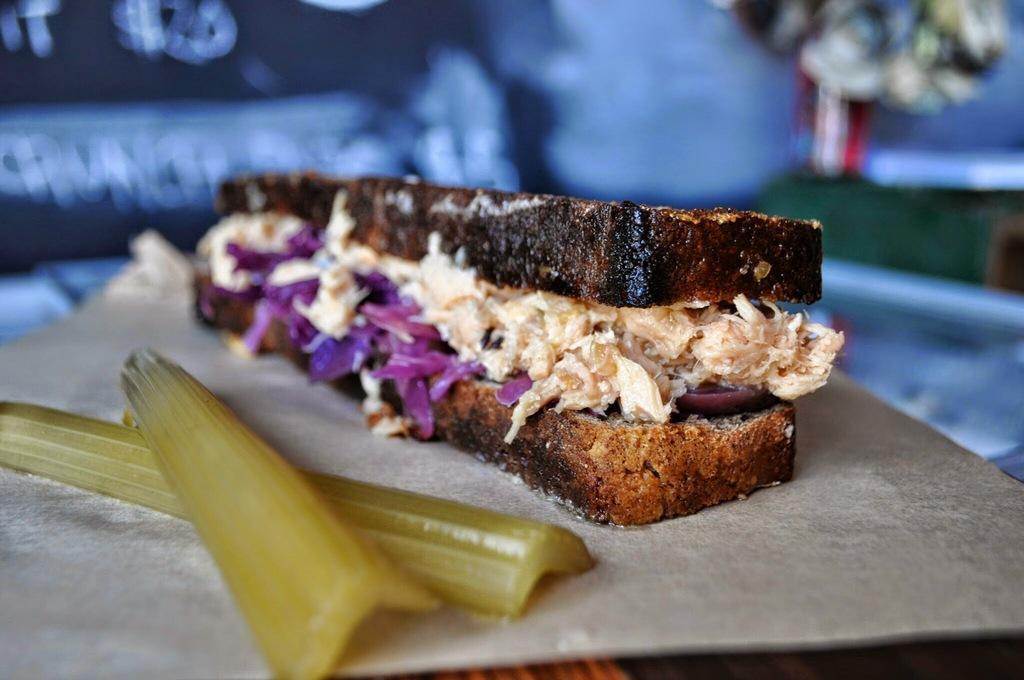In one or two sentences, can you explain what this image depicts? On the table we can see sandwich, bread and vegetable. On the top right corner there is a flower pot. Here we can see banner. 